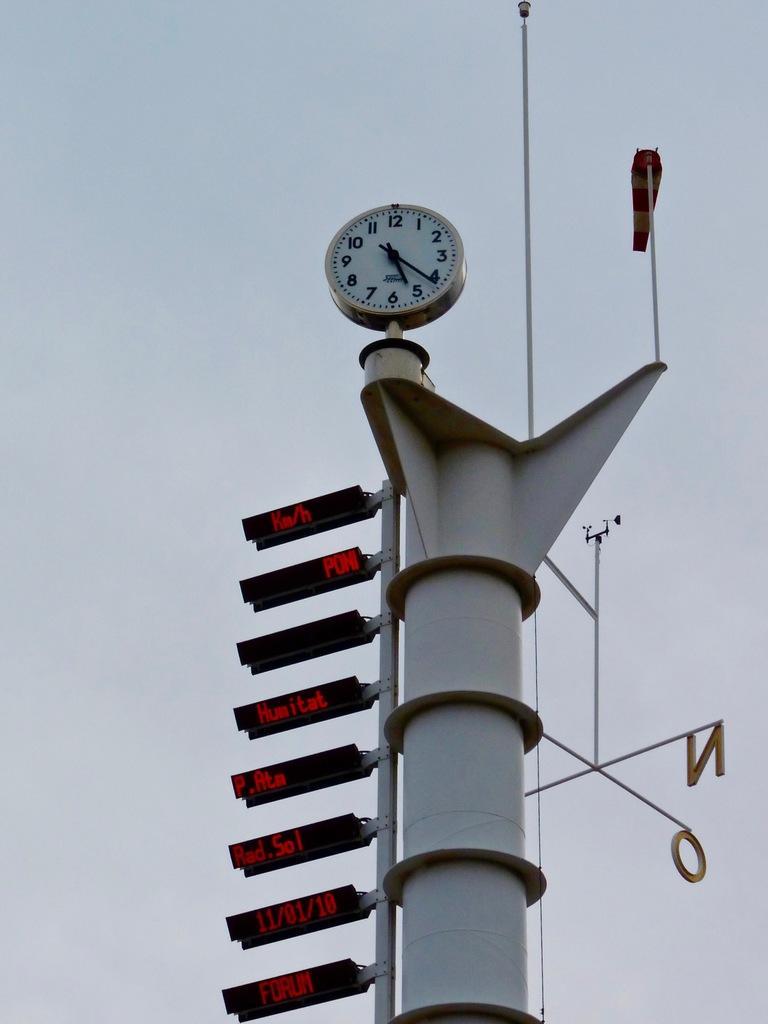Can you describe this image briefly? In this picture I can see there is a clock and it has numbers and there is a direction board and there are few screens and there is a tower. 